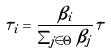<formula> <loc_0><loc_0><loc_500><loc_500>\tau _ { i } = \frac { \beta _ { i } } { \sum _ { j \in \Theta } \beta _ { j } } \tau</formula> 